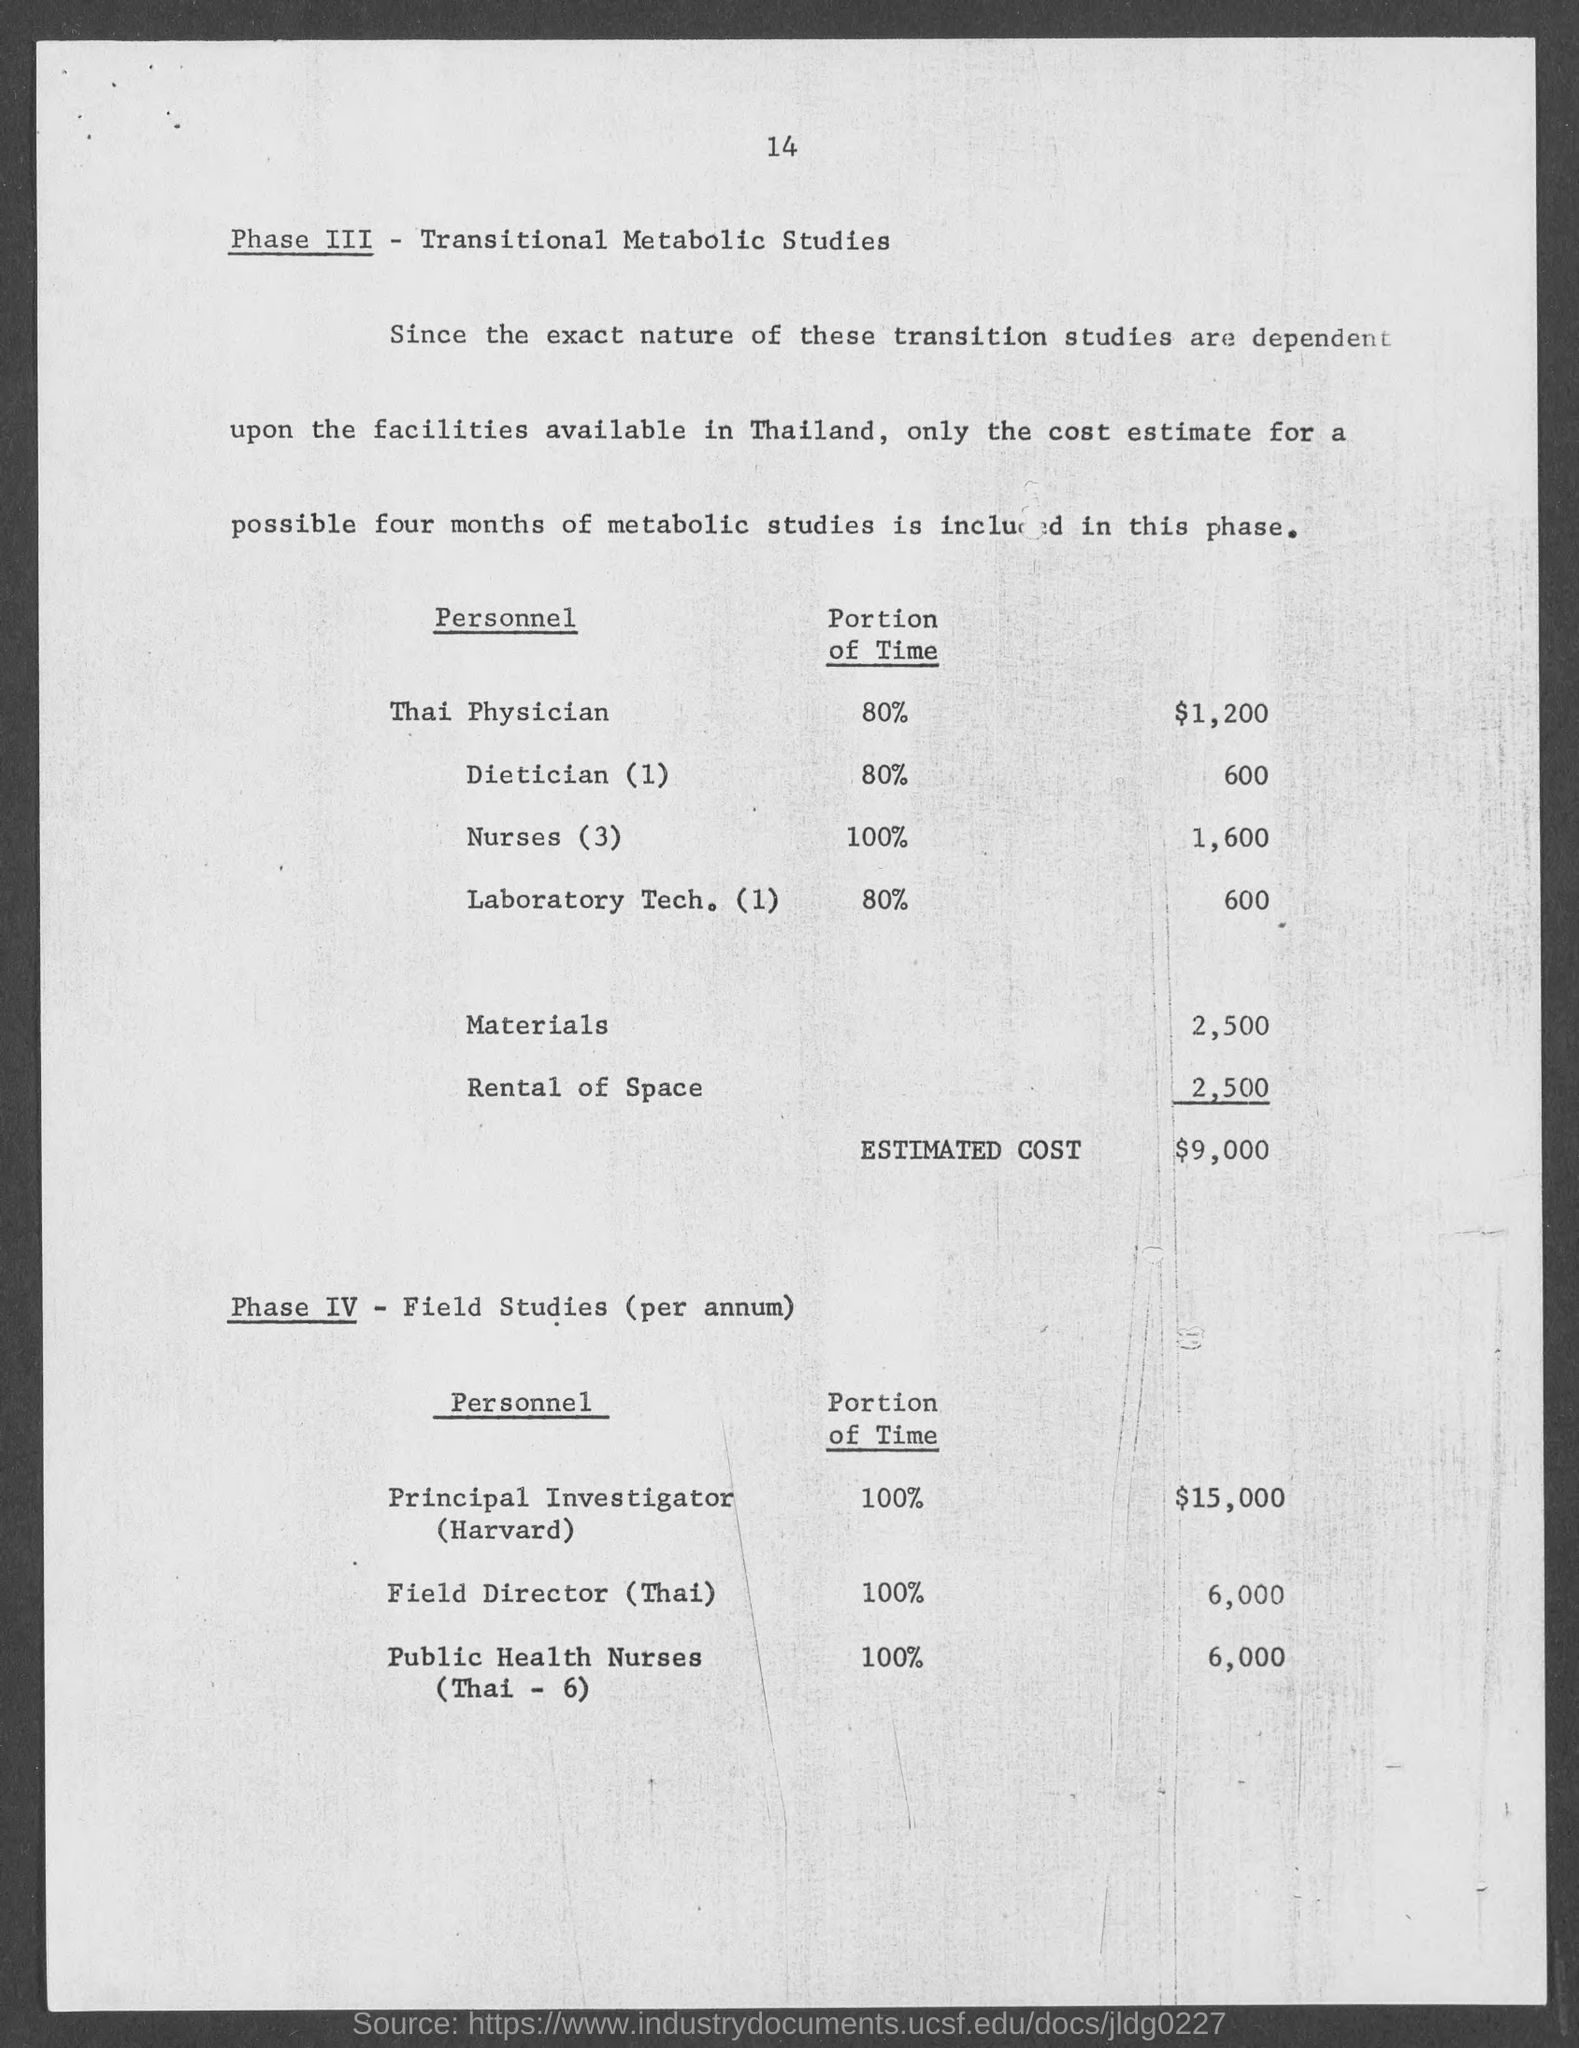Can you list the personnel involved in Phase III along with their time commitment and costs? In Phase III, the personnel and their time commitments are: Thai Physician at 80% time for $1,200, Dietician (1) at 80% for $600, Nurses (3) at 100% for $1,600, and Laboratory Technician (1) at 80% for $600. The total materials and rental space costs are $5,000, leading to an estimated cost of $9,000 for this phase. 